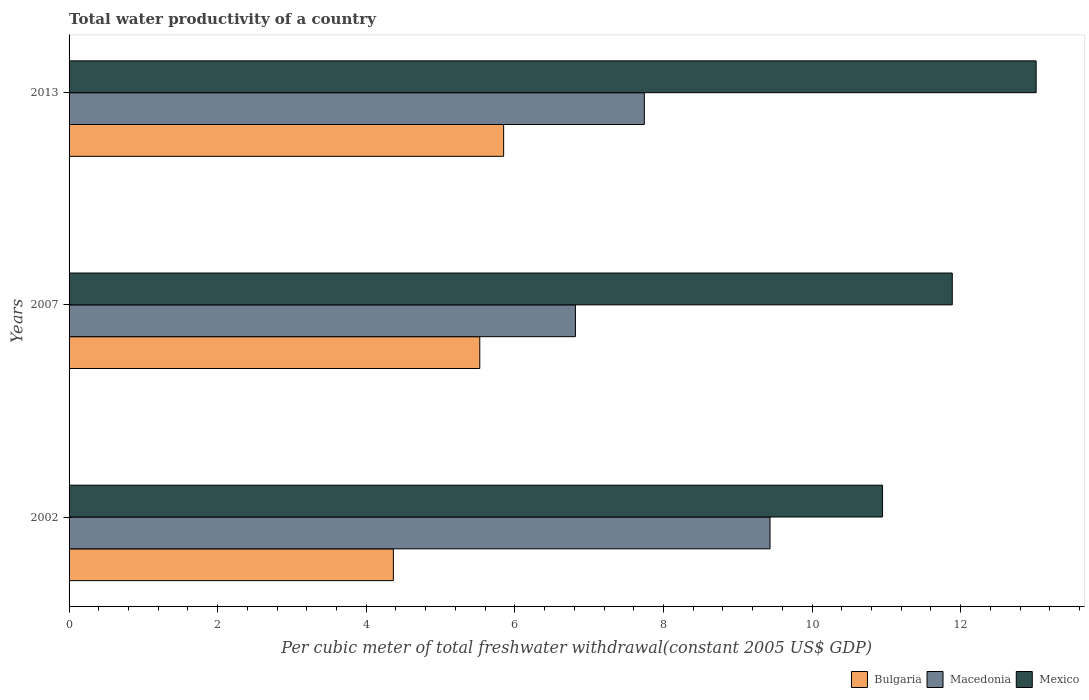Are the number of bars per tick equal to the number of legend labels?
Your answer should be compact. Yes. Are the number of bars on each tick of the Y-axis equal?
Your response must be concise. Yes. What is the label of the 1st group of bars from the top?
Your response must be concise. 2013. What is the total water productivity in Macedonia in 2002?
Give a very brief answer. 9.43. Across all years, what is the maximum total water productivity in Mexico?
Your answer should be compact. 13.02. Across all years, what is the minimum total water productivity in Bulgaria?
Make the answer very short. 4.37. What is the total total water productivity in Mexico in the graph?
Provide a succinct answer. 35.85. What is the difference between the total water productivity in Macedonia in 2002 and that in 2013?
Provide a short and direct response. 1.69. What is the difference between the total water productivity in Mexico in 2007 and the total water productivity in Macedonia in 2002?
Keep it short and to the point. 2.45. What is the average total water productivity in Macedonia per year?
Make the answer very short. 8. In the year 2007, what is the difference between the total water productivity in Mexico and total water productivity in Bulgaria?
Your response must be concise. 6.36. In how many years, is the total water productivity in Mexico greater than 12 US$?
Provide a succinct answer. 1. What is the ratio of the total water productivity in Bulgaria in 2002 to that in 2007?
Make the answer very short. 0.79. Is the total water productivity in Mexico in 2002 less than that in 2007?
Your response must be concise. Yes. Is the difference between the total water productivity in Mexico in 2002 and 2007 greater than the difference between the total water productivity in Bulgaria in 2002 and 2007?
Ensure brevity in your answer.  Yes. What is the difference between the highest and the second highest total water productivity in Bulgaria?
Your answer should be compact. 0.32. What is the difference between the highest and the lowest total water productivity in Macedonia?
Offer a very short reply. 2.62. What does the 3rd bar from the top in 2007 represents?
Make the answer very short. Bulgaria. What does the 2nd bar from the bottom in 2007 represents?
Make the answer very short. Macedonia. Are all the bars in the graph horizontal?
Offer a terse response. Yes. How many years are there in the graph?
Your answer should be compact. 3. Does the graph contain any zero values?
Give a very brief answer. No. What is the title of the graph?
Your answer should be compact. Total water productivity of a country. Does "Ukraine" appear as one of the legend labels in the graph?
Your response must be concise. No. What is the label or title of the X-axis?
Your answer should be very brief. Per cubic meter of total freshwater withdrawal(constant 2005 US$ GDP). What is the Per cubic meter of total freshwater withdrawal(constant 2005 US$ GDP) in Bulgaria in 2002?
Offer a very short reply. 4.37. What is the Per cubic meter of total freshwater withdrawal(constant 2005 US$ GDP) of Macedonia in 2002?
Keep it short and to the point. 9.43. What is the Per cubic meter of total freshwater withdrawal(constant 2005 US$ GDP) in Mexico in 2002?
Keep it short and to the point. 10.95. What is the Per cubic meter of total freshwater withdrawal(constant 2005 US$ GDP) in Bulgaria in 2007?
Offer a very short reply. 5.53. What is the Per cubic meter of total freshwater withdrawal(constant 2005 US$ GDP) in Macedonia in 2007?
Offer a terse response. 6.82. What is the Per cubic meter of total freshwater withdrawal(constant 2005 US$ GDP) of Mexico in 2007?
Make the answer very short. 11.89. What is the Per cubic meter of total freshwater withdrawal(constant 2005 US$ GDP) in Bulgaria in 2013?
Provide a succinct answer. 5.85. What is the Per cubic meter of total freshwater withdrawal(constant 2005 US$ GDP) of Macedonia in 2013?
Your response must be concise. 7.74. What is the Per cubic meter of total freshwater withdrawal(constant 2005 US$ GDP) of Mexico in 2013?
Provide a short and direct response. 13.02. Across all years, what is the maximum Per cubic meter of total freshwater withdrawal(constant 2005 US$ GDP) of Bulgaria?
Provide a short and direct response. 5.85. Across all years, what is the maximum Per cubic meter of total freshwater withdrawal(constant 2005 US$ GDP) of Macedonia?
Your response must be concise. 9.43. Across all years, what is the maximum Per cubic meter of total freshwater withdrawal(constant 2005 US$ GDP) of Mexico?
Ensure brevity in your answer.  13.02. Across all years, what is the minimum Per cubic meter of total freshwater withdrawal(constant 2005 US$ GDP) in Bulgaria?
Give a very brief answer. 4.37. Across all years, what is the minimum Per cubic meter of total freshwater withdrawal(constant 2005 US$ GDP) of Macedonia?
Your answer should be very brief. 6.82. Across all years, what is the minimum Per cubic meter of total freshwater withdrawal(constant 2005 US$ GDP) in Mexico?
Provide a succinct answer. 10.95. What is the total Per cubic meter of total freshwater withdrawal(constant 2005 US$ GDP) of Bulgaria in the graph?
Your answer should be compact. 15.74. What is the total Per cubic meter of total freshwater withdrawal(constant 2005 US$ GDP) of Macedonia in the graph?
Provide a short and direct response. 23.99. What is the total Per cubic meter of total freshwater withdrawal(constant 2005 US$ GDP) of Mexico in the graph?
Offer a very short reply. 35.85. What is the difference between the Per cubic meter of total freshwater withdrawal(constant 2005 US$ GDP) of Bulgaria in 2002 and that in 2007?
Offer a terse response. -1.16. What is the difference between the Per cubic meter of total freshwater withdrawal(constant 2005 US$ GDP) of Macedonia in 2002 and that in 2007?
Your answer should be compact. 2.62. What is the difference between the Per cubic meter of total freshwater withdrawal(constant 2005 US$ GDP) in Mexico in 2002 and that in 2007?
Keep it short and to the point. -0.94. What is the difference between the Per cubic meter of total freshwater withdrawal(constant 2005 US$ GDP) of Bulgaria in 2002 and that in 2013?
Your answer should be compact. -1.48. What is the difference between the Per cubic meter of total freshwater withdrawal(constant 2005 US$ GDP) in Macedonia in 2002 and that in 2013?
Give a very brief answer. 1.69. What is the difference between the Per cubic meter of total freshwater withdrawal(constant 2005 US$ GDP) in Mexico in 2002 and that in 2013?
Provide a short and direct response. -2.07. What is the difference between the Per cubic meter of total freshwater withdrawal(constant 2005 US$ GDP) in Bulgaria in 2007 and that in 2013?
Your response must be concise. -0.32. What is the difference between the Per cubic meter of total freshwater withdrawal(constant 2005 US$ GDP) of Macedonia in 2007 and that in 2013?
Make the answer very short. -0.93. What is the difference between the Per cubic meter of total freshwater withdrawal(constant 2005 US$ GDP) in Mexico in 2007 and that in 2013?
Keep it short and to the point. -1.13. What is the difference between the Per cubic meter of total freshwater withdrawal(constant 2005 US$ GDP) in Bulgaria in 2002 and the Per cubic meter of total freshwater withdrawal(constant 2005 US$ GDP) in Macedonia in 2007?
Give a very brief answer. -2.45. What is the difference between the Per cubic meter of total freshwater withdrawal(constant 2005 US$ GDP) of Bulgaria in 2002 and the Per cubic meter of total freshwater withdrawal(constant 2005 US$ GDP) of Mexico in 2007?
Provide a succinct answer. -7.52. What is the difference between the Per cubic meter of total freshwater withdrawal(constant 2005 US$ GDP) of Macedonia in 2002 and the Per cubic meter of total freshwater withdrawal(constant 2005 US$ GDP) of Mexico in 2007?
Your answer should be very brief. -2.45. What is the difference between the Per cubic meter of total freshwater withdrawal(constant 2005 US$ GDP) in Bulgaria in 2002 and the Per cubic meter of total freshwater withdrawal(constant 2005 US$ GDP) in Macedonia in 2013?
Your answer should be very brief. -3.38. What is the difference between the Per cubic meter of total freshwater withdrawal(constant 2005 US$ GDP) in Bulgaria in 2002 and the Per cubic meter of total freshwater withdrawal(constant 2005 US$ GDP) in Mexico in 2013?
Ensure brevity in your answer.  -8.65. What is the difference between the Per cubic meter of total freshwater withdrawal(constant 2005 US$ GDP) of Macedonia in 2002 and the Per cubic meter of total freshwater withdrawal(constant 2005 US$ GDP) of Mexico in 2013?
Provide a succinct answer. -3.58. What is the difference between the Per cubic meter of total freshwater withdrawal(constant 2005 US$ GDP) in Bulgaria in 2007 and the Per cubic meter of total freshwater withdrawal(constant 2005 US$ GDP) in Macedonia in 2013?
Your answer should be very brief. -2.21. What is the difference between the Per cubic meter of total freshwater withdrawal(constant 2005 US$ GDP) in Bulgaria in 2007 and the Per cubic meter of total freshwater withdrawal(constant 2005 US$ GDP) in Mexico in 2013?
Provide a short and direct response. -7.49. What is the difference between the Per cubic meter of total freshwater withdrawal(constant 2005 US$ GDP) of Macedonia in 2007 and the Per cubic meter of total freshwater withdrawal(constant 2005 US$ GDP) of Mexico in 2013?
Offer a terse response. -6.2. What is the average Per cubic meter of total freshwater withdrawal(constant 2005 US$ GDP) in Bulgaria per year?
Make the answer very short. 5.25. What is the average Per cubic meter of total freshwater withdrawal(constant 2005 US$ GDP) of Macedonia per year?
Your answer should be compact. 8. What is the average Per cubic meter of total freshwater withdrawal(constant 2005 US$ GDP) in Mexico per year?
Your response must be concise. 11.95. In the year 2002, what is the difference between the Per cubic meter of total freshwater withdrawal(constant 2005 US$ GDP) in Bulgaria and Per cubic meter of total freshwater withdrawal(constant 2005 US$ GDP) in Macedonia?
Give a very brief answer. -5.07. In the year 2002, what is the difference between the Per cubic meter of total freshwater withdrawal(constant 2005 US$ GDP) of Bulgaria and Per cubic meter of total freshwater withdrawal(constant 2005 US$ GDP) of Mexico?
Give a very brief answer. -6.58. In the year 2002, what is the difference between the Per cubic meter of total freshwater withdrawal(constant 2005 US$ GDP) in Macedonia and Per cubic meter of total freshwater withdrawal(constant 2005 US$ GDP) in Mexico?
Offer a very short reply. -1.51. In the year 2007, what is the difference between the Per cubic meter of total freshwater withdrawal(constant 2005 US$ GDP) in Bulgaria and Per cubic meter of total freshwater withdrawal(constant 2005 US$ GDP) in Macedonia?
Keep it short and to the point. -1.29. In the year 2007, what is the difference between the Per cubic meter of total freshwater withdrawal(constant 2005 US$ GDP) in Bulgaria and Per cubic meter of total freshwater withdrawal(constant 2005 US$ GDP) in Mexico?
Offer a very short reply. -6.36. In the year 2007, what is the difference between the Per cubic meter of total freshwater withdrawal(constant 2005 US$ GDP) in Macedonia and Per cubic meter of total freshwater withdrawal(constant 2005 US$ GDP) in Mexico?
Offer a very short reply. -5.07. In the year 2013, what is the difference between the Per cubic meter of total freshwater withdrawal(constant 2005 US$ GDP) of Bulgaria and Per cubic meter of total freshwater withdrawal(constant 2005 US$ GDP) of Macedonia?
Keep it short and to the point. -1.89. In the year 2013, what is the difference between the Per cubic meter of total freshwater withdrawal(constant 2005 US$ GDP) of Bulgaria and Per cubic meter of total freshwater withdrawal(constant 2005 US$ GDP) of Mexico?
Your answer should be compact. -7.17. In the year 2013, what is the difference between the Per cubic meter of total freshwater withdrawal(constant 2005 US$ GDP) of Macedonia and Per cubic meter of total freshwater withdrawal(constant 2005 US$ GDP) of Mexico?
Provide a succinct answer. -5.27. What is the ratio of the Per cubic meter of total freshwater withdrawal(constant 2005 US$ GDP) of Bulgaria in 2002 to that in 2007?
Ensure brevity in your answer.  0.79. What is the ratio of the Per cubic meter of total freshwater withdrawal(constant 2005 US$ GDP) of Macedonia in 2002 to that in 2007?
Your response must be concise. 1.38. What is the ratio of the Per cubic meter of total freshwater withdrawal(constant 2005 US$ GDP) of Mexico in 2002 to that in 2007?
Your answer should be compact. 0.92. What is the ratio of the Per cubic meter of total freshwater withdrawal(constant 2005 US$ GDP) of Bulgaria in 2002 to that in 2013?
Give a very brief answer. 0.75. What is the ratio of the Per cubic meter of total freshwater withdrawal(constant 2005 US$ GDP) of Macedonia in 2002 to that in 2013?
Provide a succinct answer. 1.22. What is the ratio of the Per cubic meter of total freshwater withdrawal(constant 2005 US$ GDP) in Mexico in 2002 to that in 2013?
Offer a very short reply. 0.84. What is the ratio of the Per cubic meter of total freshwater withdrawal(constant 2005 US$ GDP) of Bulgaria in 2007 to that in 2013?
Offer a very short reply. 0.95. What is the ratio of the Per cubic meter of total freshwater withdrawal(constant 2005 US$ GDP) in Macedonia in 2007 to that in 2013?
Keep it short and to the point. 0.88. What is the ratio of the Per cubic meter of total freshwater withdrawal(constant 2005 US$ GDP) in Mexico in 2007 to that in 2013?
Your response must be concise. 0.91. What is the difference between the highest and the second highest Per cubic meter of total freshwater withdrawal(constant 2005 US$ GDP) of Bulgaria?
Offer a very short reply. 0.32. What is the difference between the highest and the second highest Per cubic meter of total freshwater withdrawal(constant 2005 US$ GDP) of Macedonia?
Give a very brief answer. 1.69. What is the difference between the highest and the second highest Per cubic meter of total freshwater withdrawal(constant 2005 US$ GDP) of Mexico?
Offer a terse response. 1.13. What is the difference between the highest and the lowest Per cubic meter of total freshwater withdrawal(constant 2005 US$ GDP) of Bulgaria?
Offer a very short reply. 1.48. What is the difference between the highest and the lowest Per cubic meter of total freshwater withdrawal(constant 2005 US$ GDP) in Macedonia?
Keep it short and to the point. 2.62. What is the difference between the highest and the lowest Per cubic meter of total freshwater withdrawal(constant 2005 US$ GDP) of Mexico?
Your answer should be very brief. 2.07. 